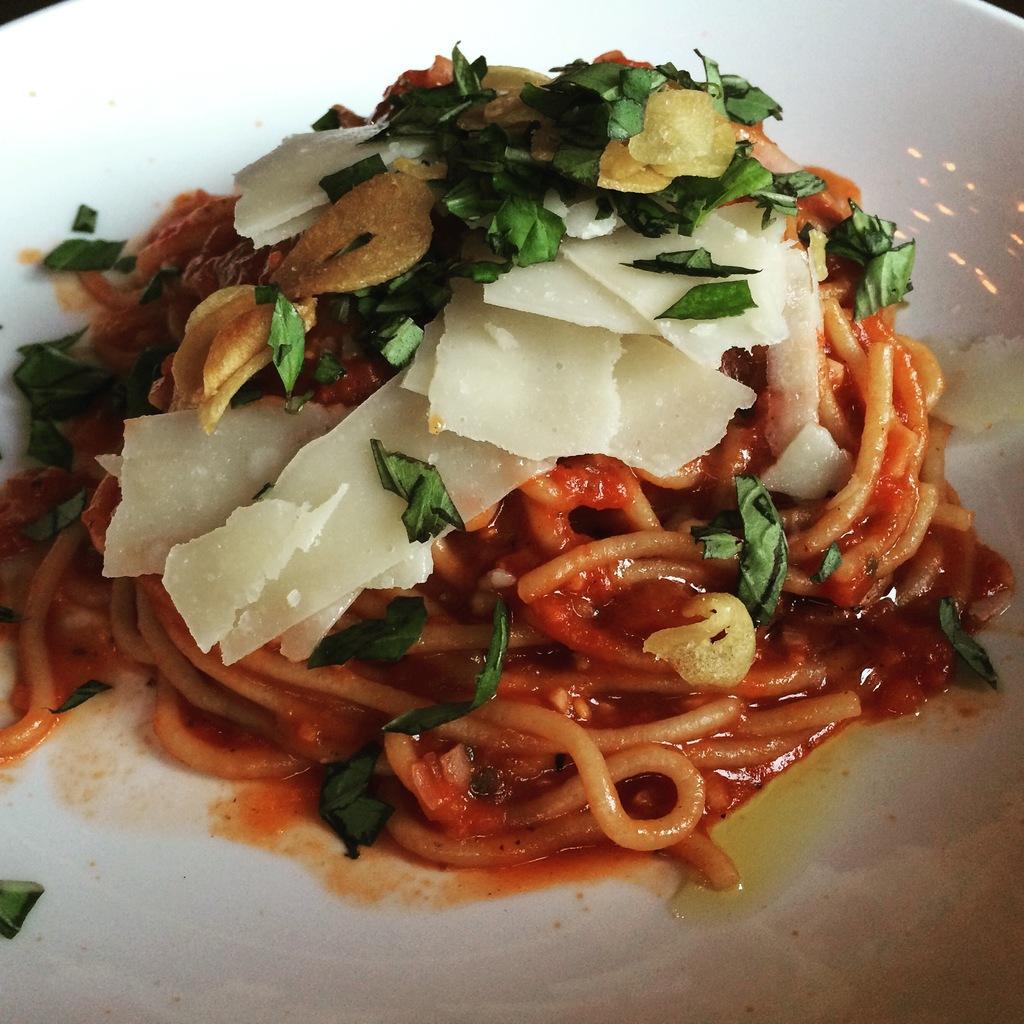In one or two sentences, can you explain what this image depicts? In this image we can see a plate containing food. 